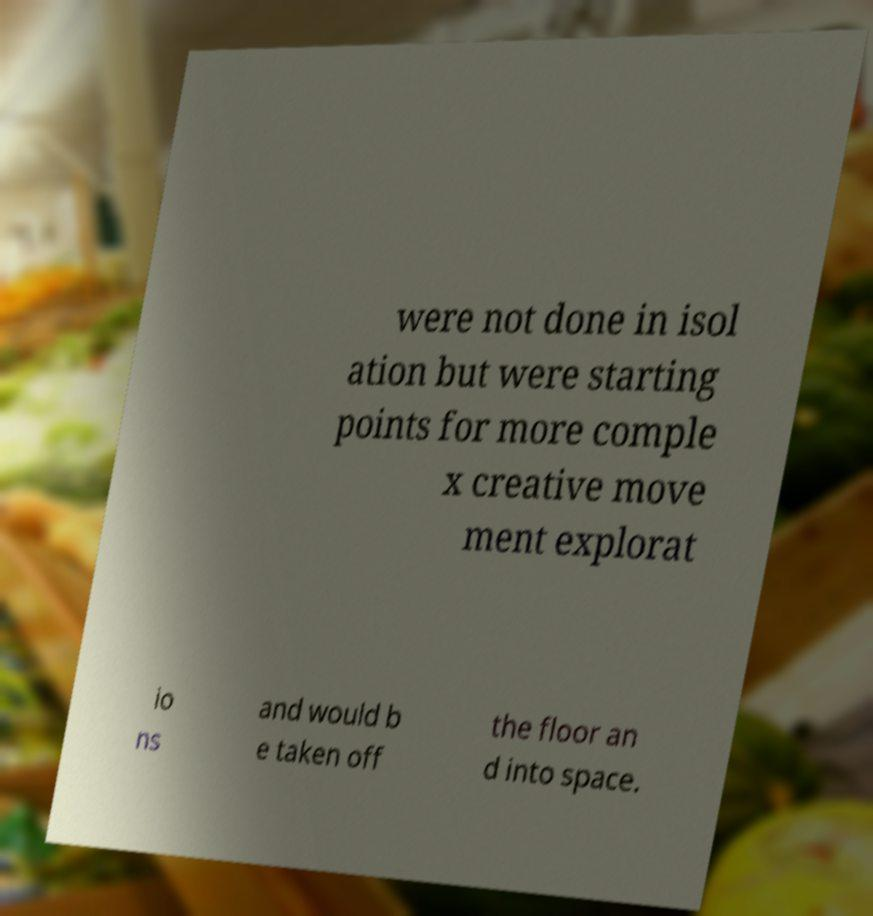Please identify and transcribe the text found in this image. were not done in isol ation but were starting points for more comple x creative move ment explorat io ns and would b e taken off the floor an d into space. 